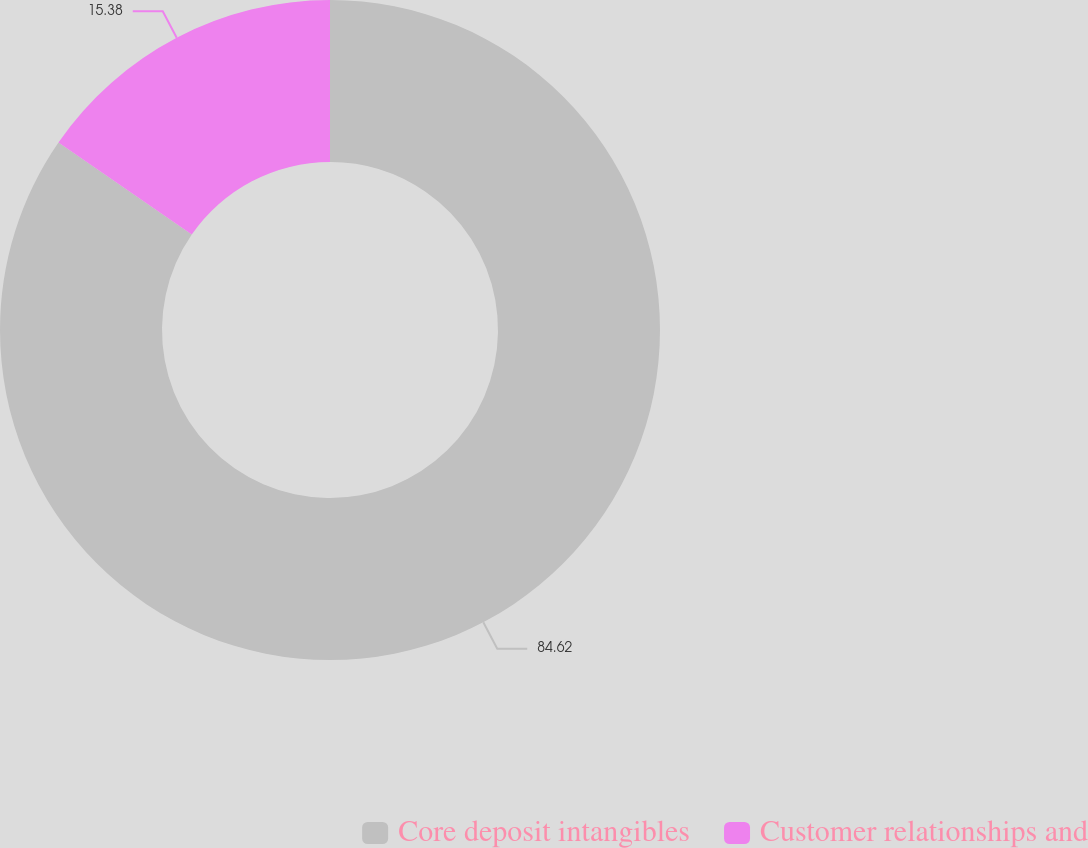Convert chart. <chart><loc_0><loc_0><loc_500><loc_500><pie_chart><fcel>Core deposit intangibles<fcel>Customer relationships and<nl><fcel>84.62%<fcel>15.38%<nl></chart> 